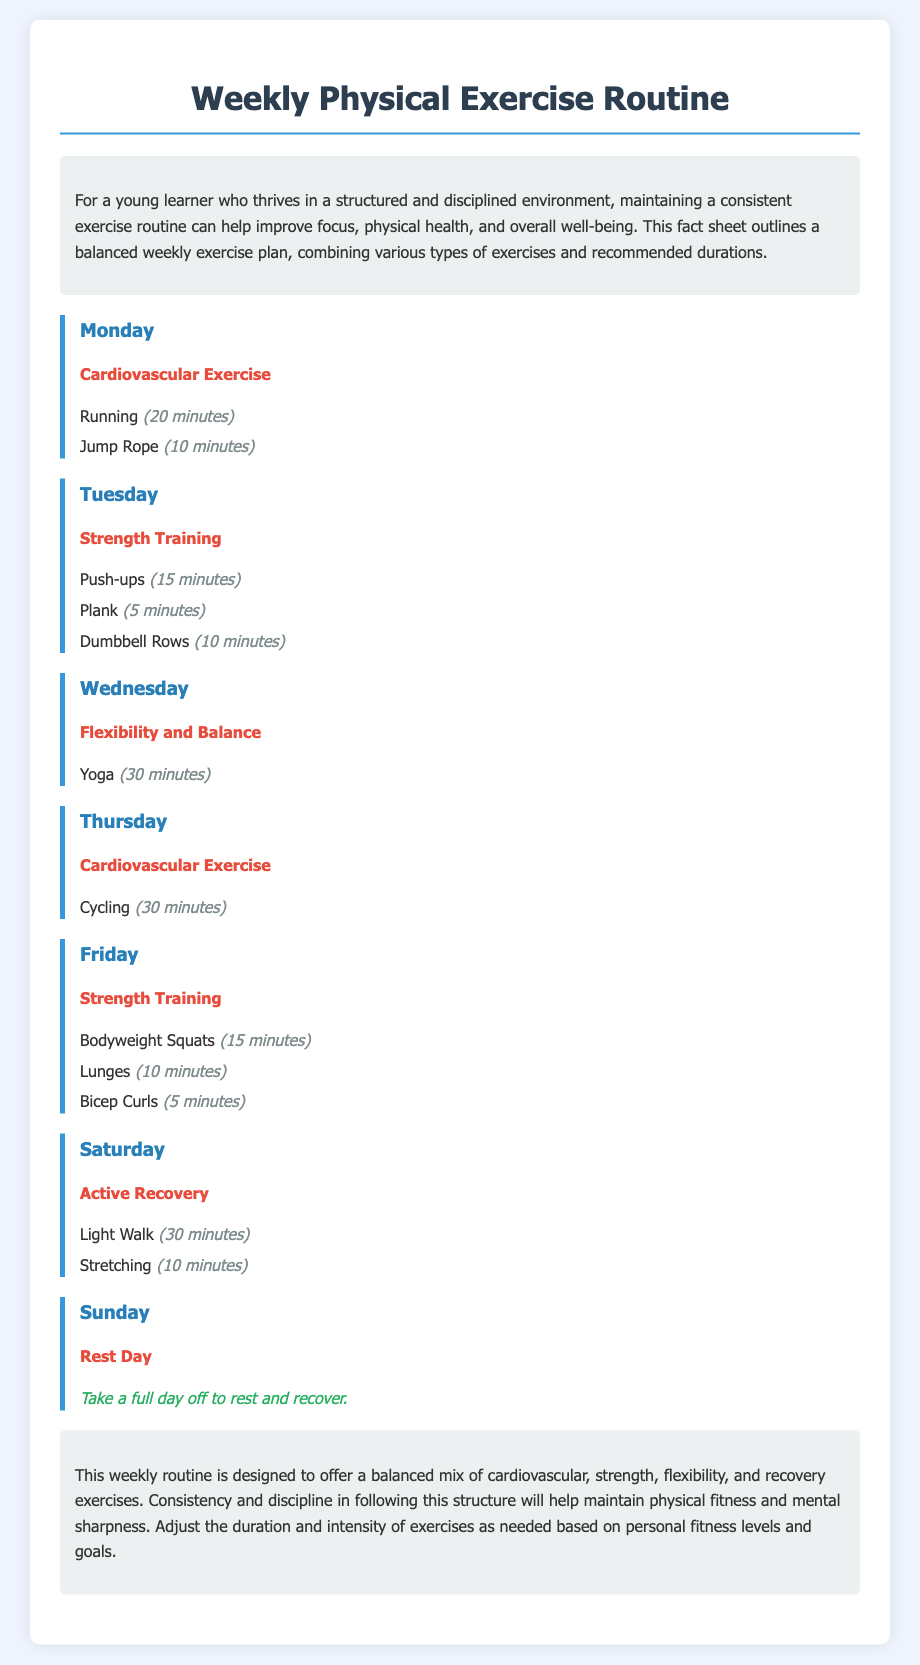what type of exercise is done on Monday? Monday lists Cardiovascular Exercise, which includes running and jump rope.
Answer: Cardiovascular Exercise how long is the yoga session on Wednesday? The document states that yoga is practiced for 30 minutes on Wednesday.
Answer: 30 minutes how many minutes does the light walk take on Saturday? Saturday includes a light walk for 30 minutes, as detailed in the exercise routine.
Answer: 30 minutes what is the total duration of strength training on Tuesday? The duration is obtained by summing the individual strengthening exercises: 15 + 5 + 10 = 30 minutes.
Answer: 30 minutes what activity is suggested for the rest day on Sunday? On Sunday, the document specifies a full day off to rest and recover.
Answer: Rest which exercise type is performed for 10 minutes on Monday? Monday features jump rope, which is done for 10 minutes according to the document.
Answer: Jump Rope which type of exercise is included in both Monday and Thursday? The exercise type listed for both Monday and Thursday is Cardiovascular Exercise.
Answer: Cardiovascular Exercise what is indicated for Saturday in terms of exercise intensity? The document classifies Saturday's session as Active Recovery, suggesting lighter activities.
Answer: Active Recovery 